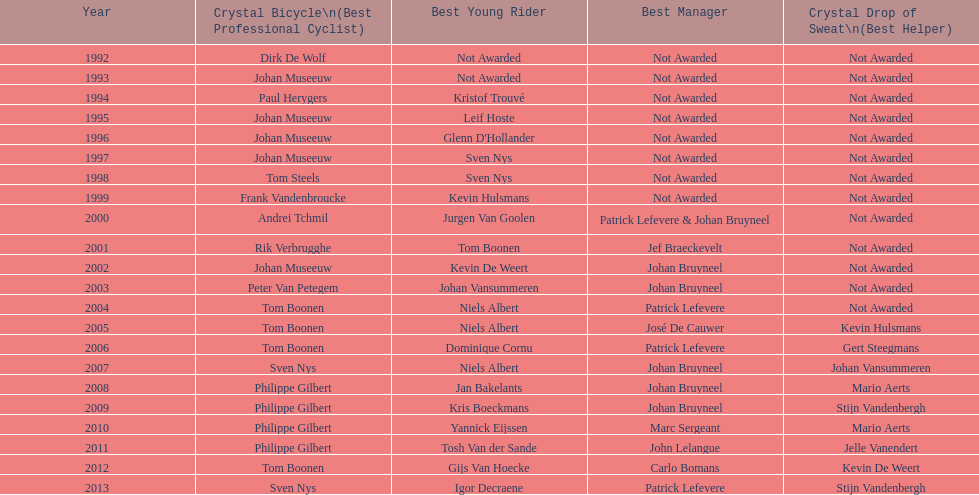Who won the crystal bicycle earlier, boonen or nys? Tom Boonen. 